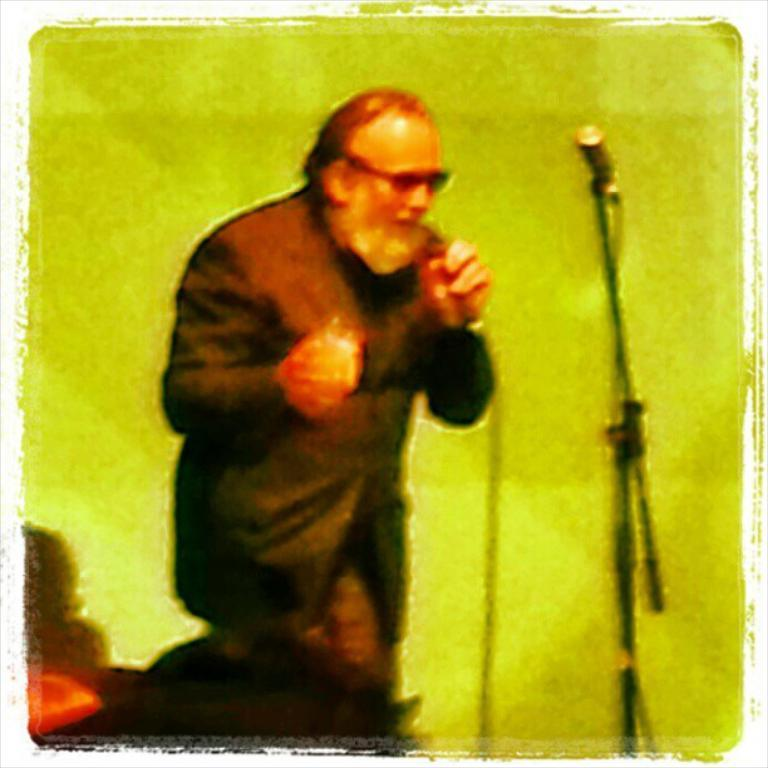What is the main subject of the image? There is a person in the image. What is the person holding in his hands? The person is holding a microphone in his hands. Is there another microphone visible in the image? Yes, there is another microphone in front of the person. What type of cloud can be seen in the image? There is no cloud present in the image; it features a person holding a microphone and another microphone in front of him. How does the zephyr affect the person in the image? There is no mention of a zephyr or any wind in the image, so its effect cannot be determined. 